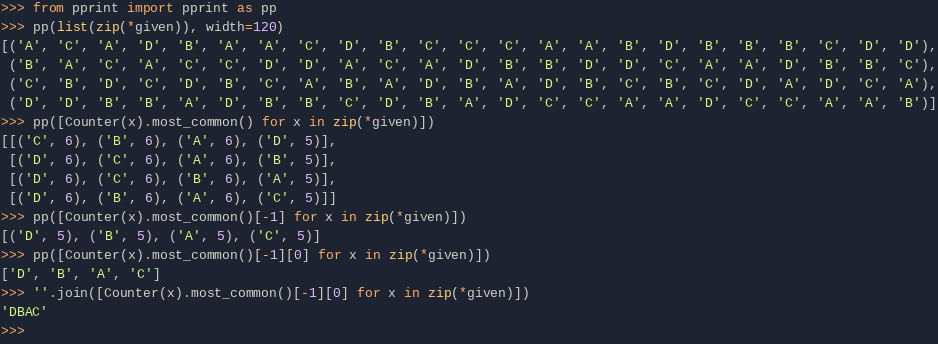<code> <loc_0><loc_0><loc_500><loc_500><_Python_>>>> from pprint import pprint as pp
>>> pp(list(zip(*given)), width=120)
[('A', 'C', 'A', 'D', 'B', 'A', 'A', 'C', 'D', 'B', 'C', 'C', 'C', 'A', 'A', 'B', 'D', 'B', 'B', 'B', 'C', 'D', 'D'),
 ('B', 'A', 'C', 'A', 'C', 'C', 'D', 'D', 'A', 'C', 'A', 'D', 'B', 'B', 'D', 'D', 'C', 'A', 'A', 'D', 'B', 'B', 'C'),
 ('C', 'B', 'D', 'C', 'D', 'B', 'C', 'A', 'B', 'A', 'D', 'B', 'A', 'D', 'B', 'C', 'B', 'C', 'D', 'A', 'D', 'C', 'A'),
 ('D', 'D', 'B', 'B', 'A', 'D', 'B', 'B', 'C', 'D', 'B', 'A', 'D', 'C', 'C', 'A', 'A', 'D', 'C', 'C', 'A', 'A', 'B')]
>>> pp([Counter(x).most_common() for x in zip(*given)])
[[('C', 6), ('B', 6), ('A', 6), ('D', 5)],
 [('D', 6), ('C', 6), ('A', 6), ('B', 5)],
 [('D', 6), ('C', 6), ('B', 6), ('A', 5)],
 [('D', 6), ('B', 6), ('A', 6), ('C', 5)]]
>>> pp([Counter(x).most_common()[-1] for x in zip(*given)])
[('D', 5), ('B', 5), ('A', 5), ('C', 5)]
>>> pp([Counter(x).most_common()[-1][0] for x in zip(*given)])
['D', 'B', 'A', 'C']
>>> ''.join([Counter(x).most_common()[-1][0] for x in zip(*given)])
'DBAC'
>>>
</code> 